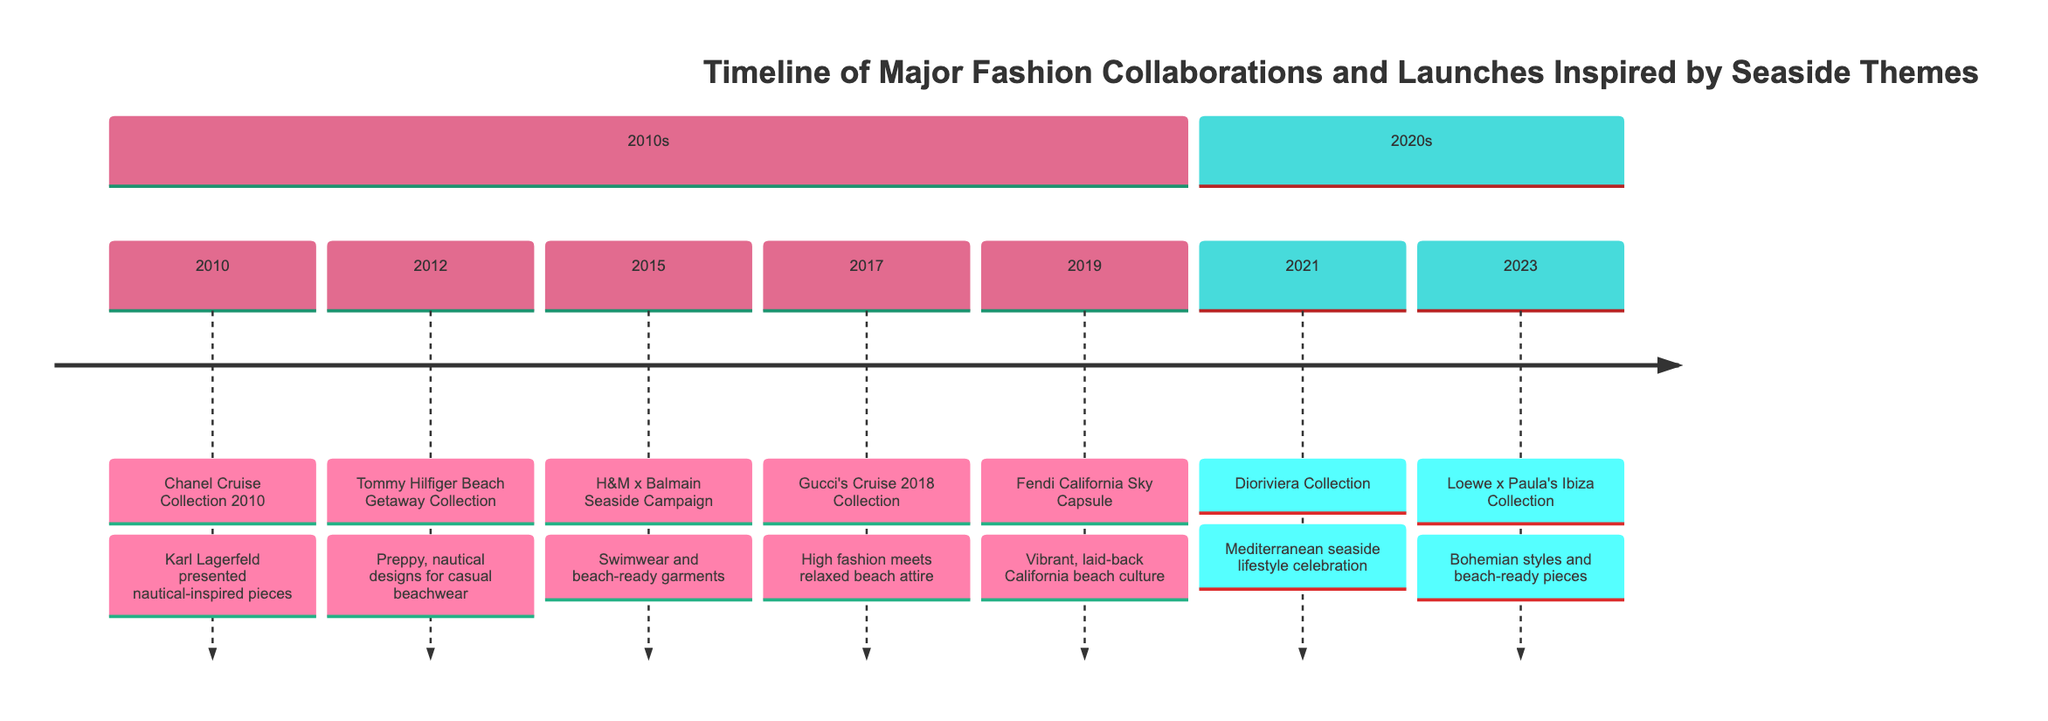What is the event in 2010? The timeline shows the event listed for the year 2010 is the "Chanel Cruise Collection 2010." This can be found in the first section under the year 2010.
Answer: Chanel Cruise Collection 2010 How many events are listed in the 2010s section? Counting the events in the 2010s section of the timeline, I can identify five events: 2010, 2012, 2015, 2017, and 2019. Therefore, the total is five.
Answer: 5 Which brand launched the Beach Getaway Collection? The timeline specifies that the "Tommy Hilfiger Beach Getaway Collection" was launched in 2012. Hence, the brand is Tommy Hilfiger.
Answer: Tommy Hilfiger What is the main theme of the 2021 event? The event in 2021 is the "Dioriviera Collection," which focuses on celebrating the Mediterranean seaside lifestyle. This description is clearly stated in the timeline.
Answer: Mediterranean seaside lifestyle Compare the events of 2015 and 2019. What is the difference in themes? The event of 2015 is the "H&M x Balmain Seaside Campaign," which involves swimwear and beach-ready garments. In contrast, the 2019 event, "Fendi California Sky Capsule," is inspired by California beach culture. Therefore, the difference lies in the specific inspirations: one is focused on swimwear while the other is centered on thematic culture.
Answer: Swimwear vs. California beach culture What type of fashion style did Gucci's 2017 event incorporate? According to the timeline, Gucci's Cruise 2018 Collection includes "high fashion meets relaxed beach attire." This indicates a blend of both high fashion and casual beach styles.
Answer: High fashion and relaxed beach attire When did the Loewe x Paula's Ibiza Collection launch? The timeline clearly indicates that the Loewe x Paula's Ibiza Collection was launched in 2023. This is marked under the 2020s section.
Answer: 2023 What does the Fendi California Sky Capsule celebrate? The timeline states that the "Fendi California Sky Capsule" celebrates vibrant, laid-back California beach culture, highlighting the different aspects of beach living.
Answer: California beach culture 